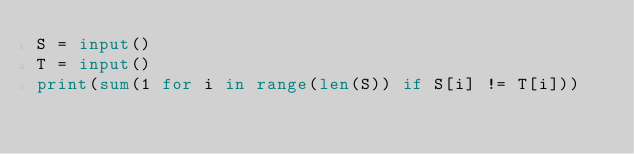Convert code to text. <code><loc_0><loc_0><loc_500><loc_500><_Python_>S = input()
T = input()
print(sum(1 for i in range(len(S)) if S[i] != T[i]))</code> 